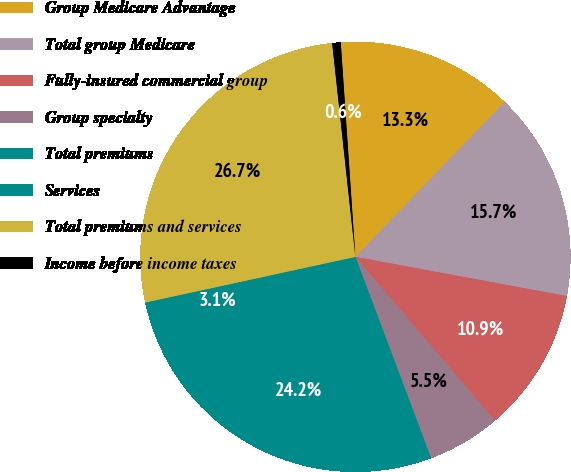<chart> <loc_0><loc_0><loc_500><loc_500><pie_chart><fcel>Group Medicare Advantage<fcel>Total group Medicare<fcel>Fully-insured commercial group<fcel>Group specialty<fcel>Total premiums<fcel>Services<fcel>Total premiums and services<fcel>Income before income taxes<nl><fcel>13.28%<fcel>15.72%<fcel>10.85%<fcel>5.51%<fcel>24.25%<fcel>3.07%<fcel>26.68%<fcel>0.64%<nl></chart> 